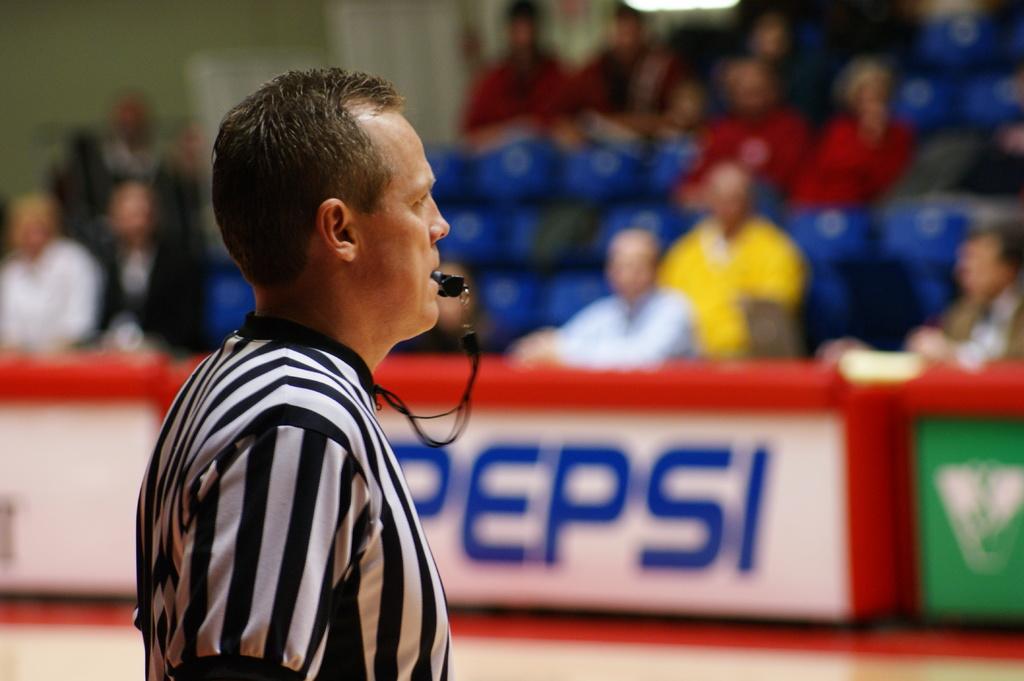In one or two sentences, can you explain what this image depicts? In this image there is a man standing with whistle in mouth, beside him there is a fence and people sitting on the chairs. 